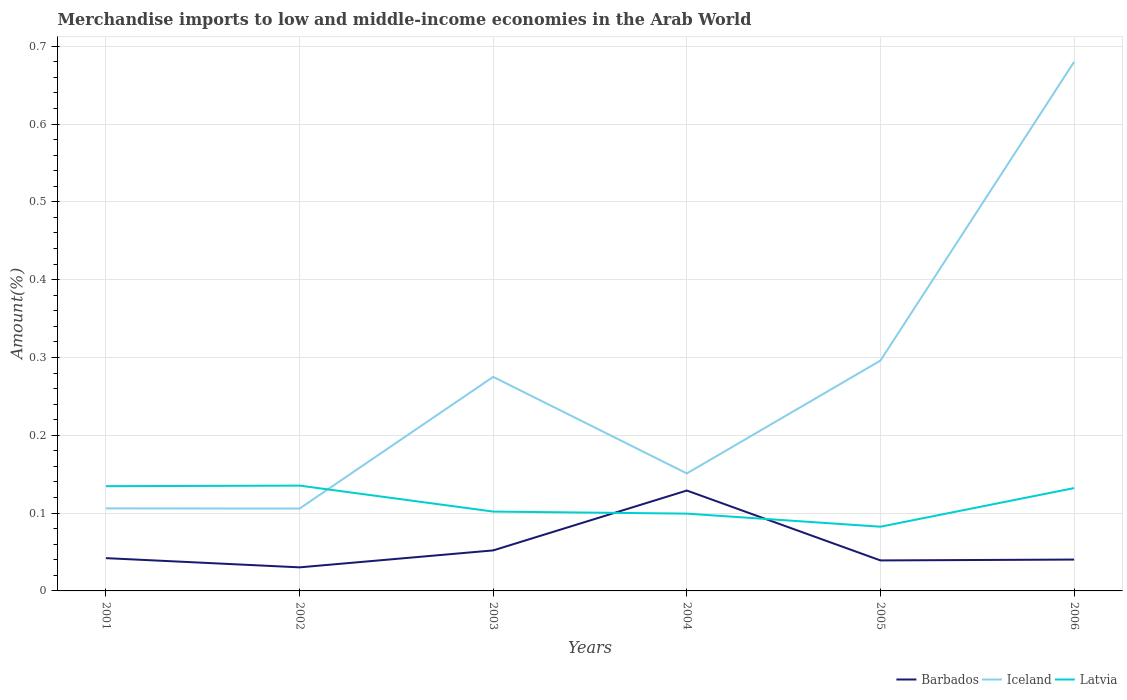Is the number of lines equal to the number of legend labels?
Your answer should be very brief. Yes. Across all years, what is the maximum percentage of amount earned from merchandise imports in Latvia?
Provide a short and direct response. 0.08. What is the total percentage of amount earned from merchandise imports in Iceland in the graph?
Keep it short and to the point. 0.12. What is the difference between the highest and the second highest percentage of amount earned from merchandise imports in Barbados?
Provide a succinct answer. 0.1. Is the percentage of amount earned from merchandise imports in Iceland strictly greater than the percentage of amount earned from merchandise imports in Latvia over the years?
Provide a succinct answer. No. How are the legend labels stacked?
Your answer should be very brief. Horizontal. What is the title of the graph?
Your answer should be compact. Merchandise imports to low and middle-income economies in the Arab World. Does "Channel Islands" appear as one of the legend labels in the graph?
Offer a terse response. No. What is the label or title of the Y-axis?
Give a very brief answer. Amount(%). What is the Amount(%) in Barbados in 2001?
Your answer should be very brief. 0.04. What is the Amount(%) of Iceland in 2001?
Provide a short and direct response. 0.11. What is the Amount(%) of Latvia in 2001?
Your answer should be very brief. 0.13. What is the Amount(%) in Barbados in 2002?
Your answer should be compact. 0.03. What is the Amount(%) of Iceland in 2002?
Offer a very short reply. 0.11. What is the Amount(%) in Latvia in 2002?
Make the answer very short. 0.14. What is the Amount(%) of Barbados in 2003?
Provide a succinct answer. 0.05. What is the Amount(%) of Iceland in 2003?
Your answer should be compact. 0.28. What is the Amount(%) of Latvia in 2003?
Ensure brevity in your answer.  0.1. What is the Amount(%) in Barbados in 2004?
Ensure brevity in your answer.  0.13. What is the Amount(%) in Iceland in 2004?
Make the answer very short. 0.15. What is the Amount(%) in Latvia in 2004?
Make the answer very short. 0.1. What is the Amount(%) of Barbados in 2005?
Your answer should be compact. 0.04. What is the Amount(%) in Iceland in 2005?
Offer a terse response. 0.3. What is the Amount(%) in Latvia in 2005?
Provide a short and direct response. 0.08. What is the Amount(%) of Barbados in 2006?
Your answer should be compact. 0.04. What is the Amount(%) in Iceland in 2006?
Make the answer very short. 0.68. What is the Amount(%) of Latvia in 2006?
Your answer should be very brief. 0.13. Across all years, what is the maximum Amount(%) of Barbados?
Make the answer very short. 0.13. Across all years, what is the maximum Amount(%) in Iceland?
Offer a terse response. 0.68. Across all years, what is the maximum Amount(%) of Latvia?
Keep it short and to the point. 0.14. Across all years, what is the minimum Amount(%) of Barbados?
Your answer should be very brief. 0.03. Across all years, what is the minimum Amount(%) of Iceland?
Offer a terse response. 0.11. Across all years, what is the minimum Amount(%) in Latvia?
Keep it short and to the point. 0.08. What is the total Amount(%) in Barbados in the graph?
Ensure brevity in your answer.  0.33. What is the total Amount(%) of Iceland in the graph?
Make the answer very short. 1.61. What is the total Amount(%) in Latvia in the graph?
Your answer should be very brief. 0.69. What is the difference between the Amount(%) of Barbados in 2001 and that in 2002?
Offer a very short reply. 0.01. What is the difference between the Amount(%) of Latvia in 2001 and that in 2002?
Provide a short and direct response. -0. What is the difference between the Amount(%) of Barbados in 2001 and that in 2003?
Keep it short and to the point. -0.01. What is the difference between the Amount(%) of Iceland in 2001 and that in 2003?
Your answer should be compact. -0.17. What is the difference between the Amount(%) of Latvia in 2001 and that in 2003?
Provide a succinct answer. 0.03. What is the difference between the Amount(%) of Barbados in 2001 and that in 2004?
Offer a terse response. -0.09. What is the difference between the Amount(%) in Iceland in 2001 and that in 2004?
Your response must be concise. -0.04. What is the difference between the Amount(%) in Latvia in 2001 and that in 2004?
Ensure brevity in your answer.  0.04. What is the difference between the Amount(%) in Barbados in 2001 and that in 2005?
Make the answer very short. 0. What is the difference between the Amount(%) in Iceland in 2001 and that in 2005?
Give a very brief answer. -0.19. What is the difference between the Amount(%) of Latvia in 2001 and that in 2005?
Your answer should be compact. 0.05. What is the difference between the Amount(%) of Barbados in 2001 and that in 2006?
Ensure brevity in your answer.  0. What is the difference between the Amount(%) of Iceland in 2001 and that in 2006?
Offer a very short reply. -0.57. What is the difference between the Amount(%) in Latvia in 2001 and that in 2006?
Ensure brevity in your answer.  0. What is the difference between the Amount(%) in Barbados in 2002 and that in 2003?
Keep it short and to the point. -0.02. What is the difference between the Amount(%) of Iceland in 2002 and that in 2003?
Make the answer very short. -0.17. What is the difference between the Amount(%) in Latvia in 2002 and that in 2003?
Ensure brevity in your answer.  0.03. What is the difference between the Amount(%) of Barbados in 2002 and that in 2004?
Your answer should be compact. -0.1. What is the difference between the Amount(%) in Iceland in 2002 and that in 2004?
Offer a terse response. -0.05. What is the difference between the Amount(%) of Latvia in 2002 and that in 2004?
Keep it short and to the point. 0.04. What is the difference between the Amount(%) of Barbados in 2002 and that in 2005?
Your answer should be very brief. -0.01. What is the difference between the Amount(%) of Iceland in 2002 and that in 2005?
Provide a short and direct response. -0.19. What is the difference between the Amount(%) in Latvia in 2002 and that in 2005?
Make the answer very short. 0.05. What is the difference between the Amount(%) in Barbados in 2002 and that in 2006?
Give a very brief answer. -0.01. What is the difference between the Amount(%) of Iceland in 2002 and that in 2006?
Provide a succinct answer. -0.57. What is the difference between the Amount(%) of Latvia in 2002 and that in 2006?
Ensure brevity in your answer.  0. What is the difference between the Amount(%) of Barbados in 2003 and that in 2004?
Ensure brevity in your answer.  -0.08. What is the difference between the Amount(%) in Iceland in 2003 and that in 2004?
Offer a terse response. 0.12. What is the difference between the Amount(%) in Latvia in 2003 and that in 2004?
Your answer should be very brief. 0. What is the difference between the Amount(%) of Barbados in 2003 and that in 2005?
Your response must be concise. 0.01. What is the difference between the Amount(%) of Iceland in 2003 and that in 2005?
Ensure brevity in your answer.  -0.02. What is the difference between the Amount(%) in Latvia in 2003 and that in 2005?
Provide a succinct answer. 0.02. What is the difference between the Amount(%) of Barbados in 2003 and that in 2006?
Keep it short and to the point. 0.01. What is the difference between the Amount(%) in Iceland in 2003 and that in 2006?
Your response must be concise. -0.4. What is the difference between the Amount(%) in Latvia in 2003 and that in 2006?
Make the answer very short. -0.03. What is the difference between the Amount(%) of Barbados in 2004 and that in 2005?
Provide a succinct answer. 0.09. What is the difference between the Amount(%) of Iceland in 2004 and that in 2005?
Provide a short and direct response. -0.15. What is the difference between the Amount(%) in Latvia in 2004 and that in 2005?
Provide a succinct answer. 0.02. What is the difference between the Amount(%) of Barbados in 2004 and that in 2006?
Make the answer very short. 0.09. What is the difference between the Amount(%) of Iceland in 2004 and that in 2006?
Offer a very short reply. -0.53. What is the difference between the Amount(%) in Latvia in 2004 and that in 2006?
Offer a very short reply. -0.03. What is the difference between the Amount(%) in Barbados in 2005 and that in 2006?
Offer a terse response. -0. What is the difference between the Amount(%) in Iceland in 2005 and that in 2006?
Your answer should be compact. -0.38. What is the difference between the Amount(%) in Latvia in 2005 and that in 2006?
Make the answer very short. -0.05. What is the difference between the Amount(%) in Barbados in 2001 and the Amount(%) in Iceland in 2002?
Keep it short and to the point. -0.06. What is the difference between the Amount(%) of Barbados in 2001 and the Amount(%) of Latvia in 2002?
Ensure brevity in your answer.  -0.09. What is the difference between the Amount(%) of Iceland in 2001 and the Amount(%) of Latvia in 2002?
Keep it short and to the point. -0.03. What is the difference between the Amount(%) of Barbados in 2001 and the Amount(%) of Iceland in 2003?
Provide a short and direct response. -0.23. What is the difference between the Amount(%) in Barbados in 2001 and the Amount(%) in Latvia in 2003?
Offer a very short reply. -0.06. What is the difference between the Amount(%) in Iceland in 2001 and the Amount(%) in Latvia in 2003?
Offer a very short reply. 0. What is the difference between the Amount(%) of Barbados in 2001 and the Amount(%) of Iceland in 2004?
Offer a terse response. -0.11. What is the difference between the Amount(%) of Barbados in 2001 and the Amount(%) of Latvia in 2004?
Ensure brevity in your answer.  -0.06. What is the difference between the Amount(%) of Iceland in 2001 and the Amount(%) of Latvia in 2004?
Your answer should be compact. 0.01. What is the difference between the Amount(%) of Barbados in 2001 and the Amount(%) of Iceland in 2005?
Your answer should be very brief. -0.25. What is the difference between the Amount(%) of Barbados in 2001 and the Amount(%) of Latvia in 2005?
Ensure brevity in your answer.  -0.04. What is the difference between the Amount(%) in Iceland in 2001 and the Amount(%) in Latvia in 2005?
Provide a short and direct response. 0.02. What is the difference between the Amount(%) of Barbados in 2001 and the Amount(%) of Iceland in 2006?
Give a very brief answer. -0.64. What is the difference between the Amount(%) in Barbados in 2001 and the Amount(%) in Latvia in 2006?
Provide a succinct answer. -0.09. What is the difference between the Amount(%) in Iceland in 2001 and the Amount(%) in Latvia in 2006?
Provide a short and direct response. -0.03. What is the difference between the Amount(%) in Barbados in 2002 and the Amount(%) in Iceland in 2003?
Ensure brevity in your answer.  -0.24. What is the difference between the Amount(%) of Barbados in 2002 and the Amount(%) of Latvia in 2003?
Make the answer very short. -0.07. What is the difference between the Amount(%) in Iceland in 2002 and the Amount(%) in Latvia in 2003?
Keep it short and to the point. 0. What is the difference between the Amount(%) in Barbados in 2002 and the Amount(%) in Iceland in 2004?
Your answer should be very brief. -0.12. What is the difference between the Amount(%) in Barbados in 2002 and the Amount(%) in Latvia in 2004?
Give a very brief answer. -0.07. What is the difference between the Amount(%) in Iceland in 2002 and the Amount(%) in Latvia in 2004?
Give a very brief answer. 0.01. What is the difference between the Amount(%) of Barbados in 2002 and the Amount(%) of Iceland in 2005?
Provide a succinct answer. -0.27. What is the difference between the Amount(%) in Barbados in 2002 and the Amount(%) in Latvia in 2005?
Give a very brief answer. -0.05. What is the difference between the Amount(%) of Iceland in 2002 and the Amount(%) of Latvia in 2005?
Provide a succinct answer. 0.02. What is the difference between the Amount(%) of Barbados in 2002 and the Amount(%) of Iceland in 2006?
Offer a very short reply. -0.65. What is the difference between the Amount(%) of Barbados in 2002 and the Amount(%) of Latvia in 2006?
Keep it short and to the point. -0.1. What is the difference between the Amount(%) in Iceland in 2002 and the Amount(%) in Latvia in 2006?
Provide a succinct answer. -0.03. What is the difference between the Amount(%) of Barbados in 2003 and the Amount(%) of Iceland in 2004?
Offer a very short reply. -0.1. What is the difference between the Amount(%) of Barbados in 2003 and the Amount(%) of Latvia in 2004?
Ensure brevity in your answer.  -0.05. What is the difference between the Amount(%) of Iceland in 2003 and the Amount(%) of Latvia in 2004?
Offer a terse response. 0.18. What is the difference between the Amount(%) in Barbados in 2003 and the Amount(%) in Iceland in 2005?
Offer a very short reply. -0.24. What is the difference between the Amount(%) of Barbados in 2003 and the Amount(%) of Latvia in 2005?
Keep it short and to the point. -0.03. What is the difference between the Amount(%) in Iceland in 2003 and the Amount(%) in Latvia in 2005?
Provide a short and direct response. 0.19. What is the difference between the Amount(%) of Barbados in 2003 and the Amount(%) of Iceland in 2006?
Offer a very short reply. -0.63. What is the difference between the Amount(%) of Barbados in 2003 and the Amount(%) of Latvia in 2006?
Offer a terse response. -0.08. What is the difference between the Amount(%) in Iceland in 2003 and the Amount(%) in Latvia in 2006?
Ensure brevity in your answer.  0.14. What is the difference between the Amount(%) of Barbados in 2004 and the Amount(%) of Iceland in 2005?
Provide a succinct answer. -0.17. What is the difference between the Amount(%) of Barbados in 2004 and the Amount(%) of Latvia in 2005?
Provide a short and direct response. 0.05. What is the difference between the Amount(%) of Iceland in 2004 and the Amount(%) of Latvia in 2005?
Provide a short and direct response. 0.07. What is the difference between the Amount(%) in Barbados in 2004 and the Amount(%) in Iceland in 2006?
Give a very brief answer. -0.55. What is the difference between the Amount(%) in Barbados in 2004 and the Amount(%) in Latvia in 2006?
Ensure brevity in your answer.  -0. What is the difference between the Amount(%) in Iceland in 2004 and the Amount(%) in Latvia in 2006?
Ensure brevity in your answer.  0.02. What is the difference between the Amount(%) of Barbados in 2005 and the Amount(%) of Iceland in 2006?
Your answer should be compact. -0.64. What is the difference between the Amount(%) of Barbados in 2005 and the Amount(%) of Latvia in 2006?
Provide a succinct answer. -0.09. What is the difference between the Amount(%) in Iceland in 2005 and the Amount(%) in Latvia in 2006?
Your answer should be compact. 0.16. What is the average Amount(%) of Barbados per year?
Your answer should be very brief. 0.06. What is the average Amount(%) in Iceland per year?
Ensure brevity in your answer.  0.27. What is the average Amount(%) of Latvia per year?
Provide a short and direct response. 0.11. In the year 2001, what is the difference between the Amount(%) in Barbados and Amount(%) in Iceland?
Provide a succinct answer. -0.06. In the year 2001, what is the difference between the Amount(%) in Barbados and Amount(%) in Latvia?
Make the answer very short. -0.09. In the year 2001, what is the difference between the Amount(%) of Iceland and Amount(%) of Latvia?
Keep it short and to the point. -0.03. In the year 2002, what is the difference between the Amount(%) of Barbados and Amount(%) of Iceland?
Ensure brevity in your answer.  -0.08. In the year 2002, what is the difference between the Amount(%) in Barbados and Amount(%) in Latvia?
Provide a short and direct response. -0.11. In the year 2002, what is the difference between the Amount(%) in Iceland and Amount(%) in Latvia?
Your answer should be compact. -0.03. In the year 2003, what is the difference between the Amount(%) in Barbados and Amount(%) in Iceland?
Offer a terse response. -0.22. In the year 2003, what is the difference between the Amount(%) in Barbados and Amount(%) in Latvia?
Your answer should be compact. -0.05. In the year 2003, what is the difference between the Amount(%) in Iceland and Amount(%) in Latvia?
Your response must be concise. 0.17. In the year 2004, what is the difference between the Amount(%) in Barbados and Amount(%) in Iceland?
Ensure brevity in your answer.  -0.02. In the year 2004, what is the difference between the Amount(%) in Barbados and Amount(%) in Latvia?
Make the answer very short. 0.03. In the year 2004, what is the difference between the Amount(%) in Iceland and Amount(%) in Latvia?
Provide a succinct answer. 0.05. In the year 2005, what is the difference between the Amount(%) in Barbados and Amount(%) in Iceland?
Ensure brevity in your answer.  -0.26. In the year 2005, what is the difference between the Amount(%) in Barbados and Amount(%) in Latvia?
Your response must be concise. -0.04. In the year 2005, what is the difference between the Amount(%) in Iceland and Amount(%) in Latvia?
Offer a very short reply. 0.21. In the year 2006, what is the difference between the Amount(%) of Barbados and Amount(%) of Iceland?
Give a very brief answer. -0.64. In the year 2006, what is the difference between the Amount(%) in Barbados and Amount(%) in Latvia?
Offer a terse response. -0.09. In the year 2006, what is the difference between the Amount(%) in Iceland and Amount(%) in Latvia?
Offer a terse response. 0.55. What is the ratio of the Amount(%) of Barbados in 2001 to that in 2002?
Your answer should be very brief. 1.39. What is the ratio of the Amount(%) in Iceland in 2001 to that in 2002?
Your answer should be very brief. 1. What is the ratio of the Amount(%) in Barbados in 2001 to that in 2003?
Ensure brevity in your answer.  0.81. What is the ratio of the Amount(%) of Iceland in 2001 to that in 2003?
Your answer should be compact. 0.39. What is the ratio of the Amount(%) of Latvia in 2001 to that in 2003?
Ensure brevity in your answer.  1.32. What is the ratio of the Amount(%) in Barbados in 2001 to that in 2004?
Ensure brevity in your answer.  0.33. What is the ratio of the Amount(%) of Iceland in 2001 to that in 2004?
Make the answer very short. 0.7. What is the ratio of the Amount(%) of Latvia in 2001 to that in 2004?
Your response must be concise. 1.35. What is the ratio of the Amount(%) of Barbados in 2001 to that in 2005?
Make the answer very short. 1.08. What is the ratio of the Amount(%) in Iceland in 2001 to that in 2005?
Ensure brevity in your answer.  0.36. What is the ratio of the Amount(%) of Latvia in 2001 to that in 2005?
Keep it short and to the point. 1.63. What is the ratio of the Amount(%) in Barbados in 2001 to that in 2006?
Give a very brief answer. 1.05. What is the ratio of the Amount(%) in Iceland in 2001 to that in 2006?
Give a very brief answer. 0.16. What is the ratio of the Amount(%) in Latvia in 2001 to that in 2006?
Your answer should be very brief. 1.02. What is the ratio of the Amount(%) of Barbados in 2002 to that in 2003?
Give a very brief answer. 0.58. What is the ratio of the Amount(%) in Iceland in 2002 to that in 2003?
Your answer should be very brief. 0.38. What is the ratio of the Amount(%) of Latvia in 2002 to that in 2003?
Provide a succinct answer. 1.33. What is the ratio of the Amount(%) in Barbados in 2002 to that in 2004?
Provide a succinct answer. 0.23. What is the ratio of the Amount(%) of Iceland in 2002 to that in 2004?
Keep it short and to the point. 0.7. What is the ratio of the Amount(%) of Latvia in 2002 to that in 2004?
Your answer should be compact. 1.36. What is the ratio of the Amount(%) in Barbados in 2002 to that in 2005?
Your answer should be compact. 0.77. What is the ratio of the Amount(%) of Iceland in 2002 to that in 2005?
Keep it short and to the point. 0.36. What is the ratio of the Amount(%) in Latvia in 2002 to that in 2005?
Offer a very short reply. 1.64. What is the ratio of the Amount(%) in Barbados in 2002 to that in 2006?
Make the answer very short. 0.75. What is the ratio of the Amount(%) of Iceland in 2002 to that in 2006?
Give a very brief answer. 0.16. What is the ratio of the Amount(%) of Latvia in 2002 to that in 2006?
Ensure brevity in your answer.  1.02. What is the ratio of the Amount(%) in Barbados in 2003 to that in 2004?
Offer a very short reply. 0.4. What is the ratio of the Amount(%) in Iceland in 2003 to that in 2004?
Give a very brief answer. 1.82. What is the ratio of the Amount(%) of Latvia in 2003 to that in 2004?
Offer a terse response. 1.03. What is the ratio of the Amount(%) of Barbados in 2003 to that in 2005?
Keep it short and to the point. 1.33. What is the ratio of the Amount(%) in Iceland in 2003 to that in 2005?
Give a very brief answer. 0.93. What is the ratio of the Amount(%) of Latvia in 2003 to that in 2005?
Your answer should be very brief. 1.24. What is the ratio of the Amount(%) of Barbados in 2003 to that in 2006?
Give a very brief answer. 1.29. What is the ratio of the Amount(%) in Iceland in 2003 to that in 2006?
Make the answer very short. 0.4. What is the ratio of the Amount(%) in Latvia in 2003 to that in 2006?
Provide a short and direct response. 0.77. What is the ratio of the Amount(%) in Barbados in 2004 to that in 2005?
Your response must be concise. 3.29. What is the ratio of the Amount(%) of Iceland in 2004 to that in 2005?
Offer a very short reply. 0.51. What is the ratio of the Amount(%) of Latvia in 2004 to that in 2005?
Offer a very short reply. 1.2. What is the ratio of the Amount(%) in Barbados in 2004 to that in 2006?
Your answer should be very brief. 3.2. What is the ratio of the Amount(%) of Iceland in 2004 to that in 2006?
Your response must be concise. 0.22. What is the ratio of the Amount(%) of Latvia in 2004 to that in 2006?
Your answer should be compact. 0.75. What is the ratio of the Amount(%) of Barbados in 2005 to that in 2006?
Give a very brief answer. 0.97. What is the ratio of the Amount(%) of Iceland in 2005 to that in 2006?
Provide a succinct answer. 0.44. What is the ratio of the Amount(%) of Latvia in 2005 to that in 2006?
Make the answer very short. 0.62. What is the difference between the highest and the second highest Amount(%) of Barbados?
Offer a terse response. 0.08. What is the difference between the highest and the second highest Amount(%) of Iceland?
Keep it short and to the point. 0.38. What is the difference between the highest and the second highest Amount(%) in Latvia?
Make the answer very short. 0. What is the difference between the highest and the lowest Amount(%) in Barbados?
Your answer should be compact. 0.1. What is the difference between the highest and the lowest Amount(%) of Iceland?
Give a very brief answer. 0.57. What is the difference between the highest and the lowest Amount(%) in Latvia?
Ensure brevity in your answer.  0.05. 